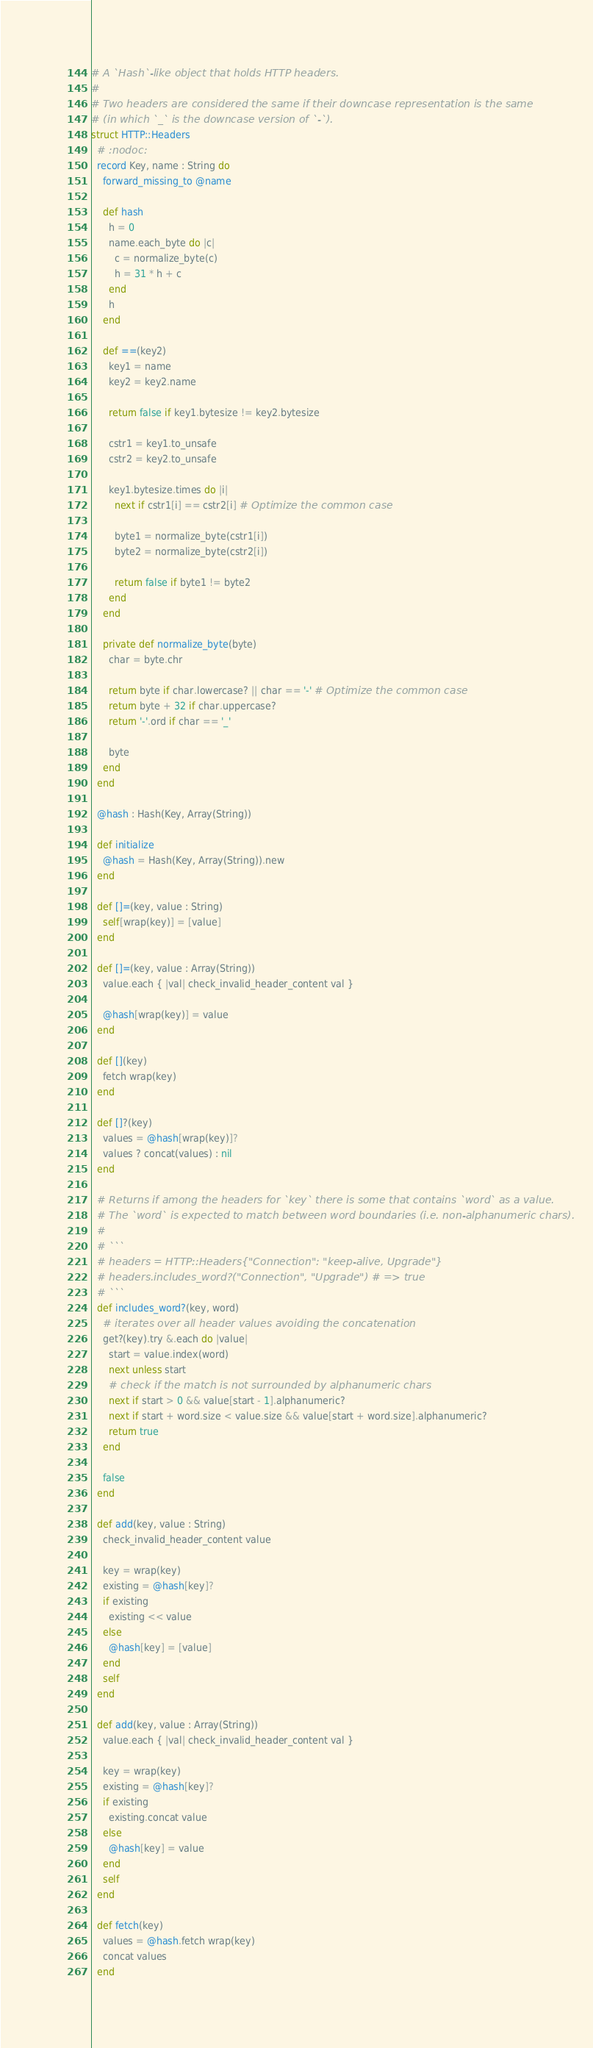<code> <loc_0><loc_0><loc_500><loc_500><_Crystal_># A `Hash`-like object that holds HTTP headers.
#
# Two headers are considered the same if their downcase representation is the same
# (in which `_` is the downcase version of `-`).
struct HTTP::Headers
  # :nodoc:
  record Key, name : String do
    forward_missing_to @name

    def hash
      h = 0
      name.each_byte do |c|
        c = normalize_byte(c)
        h = 31 * h + c
      end
      h
    end

    def ==(key2)
      key1 = name
      key2 = key2.name

      return false if key1.bytesize != key2.bytesize

      cstr1 = key1.to_unsafe
      cstr2 = key2.to_unsafe

      key1.bytesize.times do |i|
        next if cstr1[i] == cstr2[i] # Optimize the common case

        byte1 = normalize_byte(cstr1[i])
        byte2 = normalize_byte(cstr2[i])

        return false if byte1 != byte2
      end
    end

    private def normalize_byte(byte)
      char = byte.chr

      return byte if char.lowercase? || char == '-' # Optimize the common case
      return byte + 32 if char.uppercase?
      return '-'.ord if char == '_'

      byte
    end
  end

  @hash : Hash(Key, Array(String))

  def initialize
    @hash = Hash(Key, Array(String)).new
  end

  def []=(key, value : String)
    self[wrap(key)] = [value]
  end

  def []=(key, value : Array(String))
    value.each { |val| check_invalid_header_content val }

    @hash[wrap(key)] = value
  end

  def [](key)
    fetch wrap(key)
  end

  def []?(key)
    values = @hash[wrap(key)]?
    values ? concat(values) : nil
  end

  # Returns if among the headers for `key` there is some that contains `word` as a value.
  # The `word` is expected to match between word boundaries (i.e. non-alphanumeric chars).
  #
  # ```
  # headers = HTTP::Headers{"Connection": "keep-alive, Upgrade"}
  # headers.includes_word?("Connection", "Upgrade") # => true
  # ```
  def includes_word?(key, word)
    # iterates over all header values avoiding the concatenation
    get?(key).try &.each do |value|
      start = value.index(word)
      next unless start
      # check if the match is not surrounded by alphanumeric chars
      next if start > 0 && value[start - 1].alphanumeric?
      next if start + word.size < value.size && value[start + word.size].alphanumeric?
      return true
    end

    false
  end

  def add(key, value : String)
    check_invalid_header_content value

    key = wrap(key)
    existing = @hash[key]?
    if existing
      existing << value
    else
      @hash[key] = [value]
    end
    self
  end

  def add(key, value : Array(String))
    value.each { |val| check_invalid_header_content val }

    key = wrap(key)
    existing = @hash[key]?
    if existing
      existing.concat value
    else
      @hash[key] = value
    end
    self
  end

  def fetch(key)
    values = @hash.fetch wrap(key)
    concat values
  end
</code> 